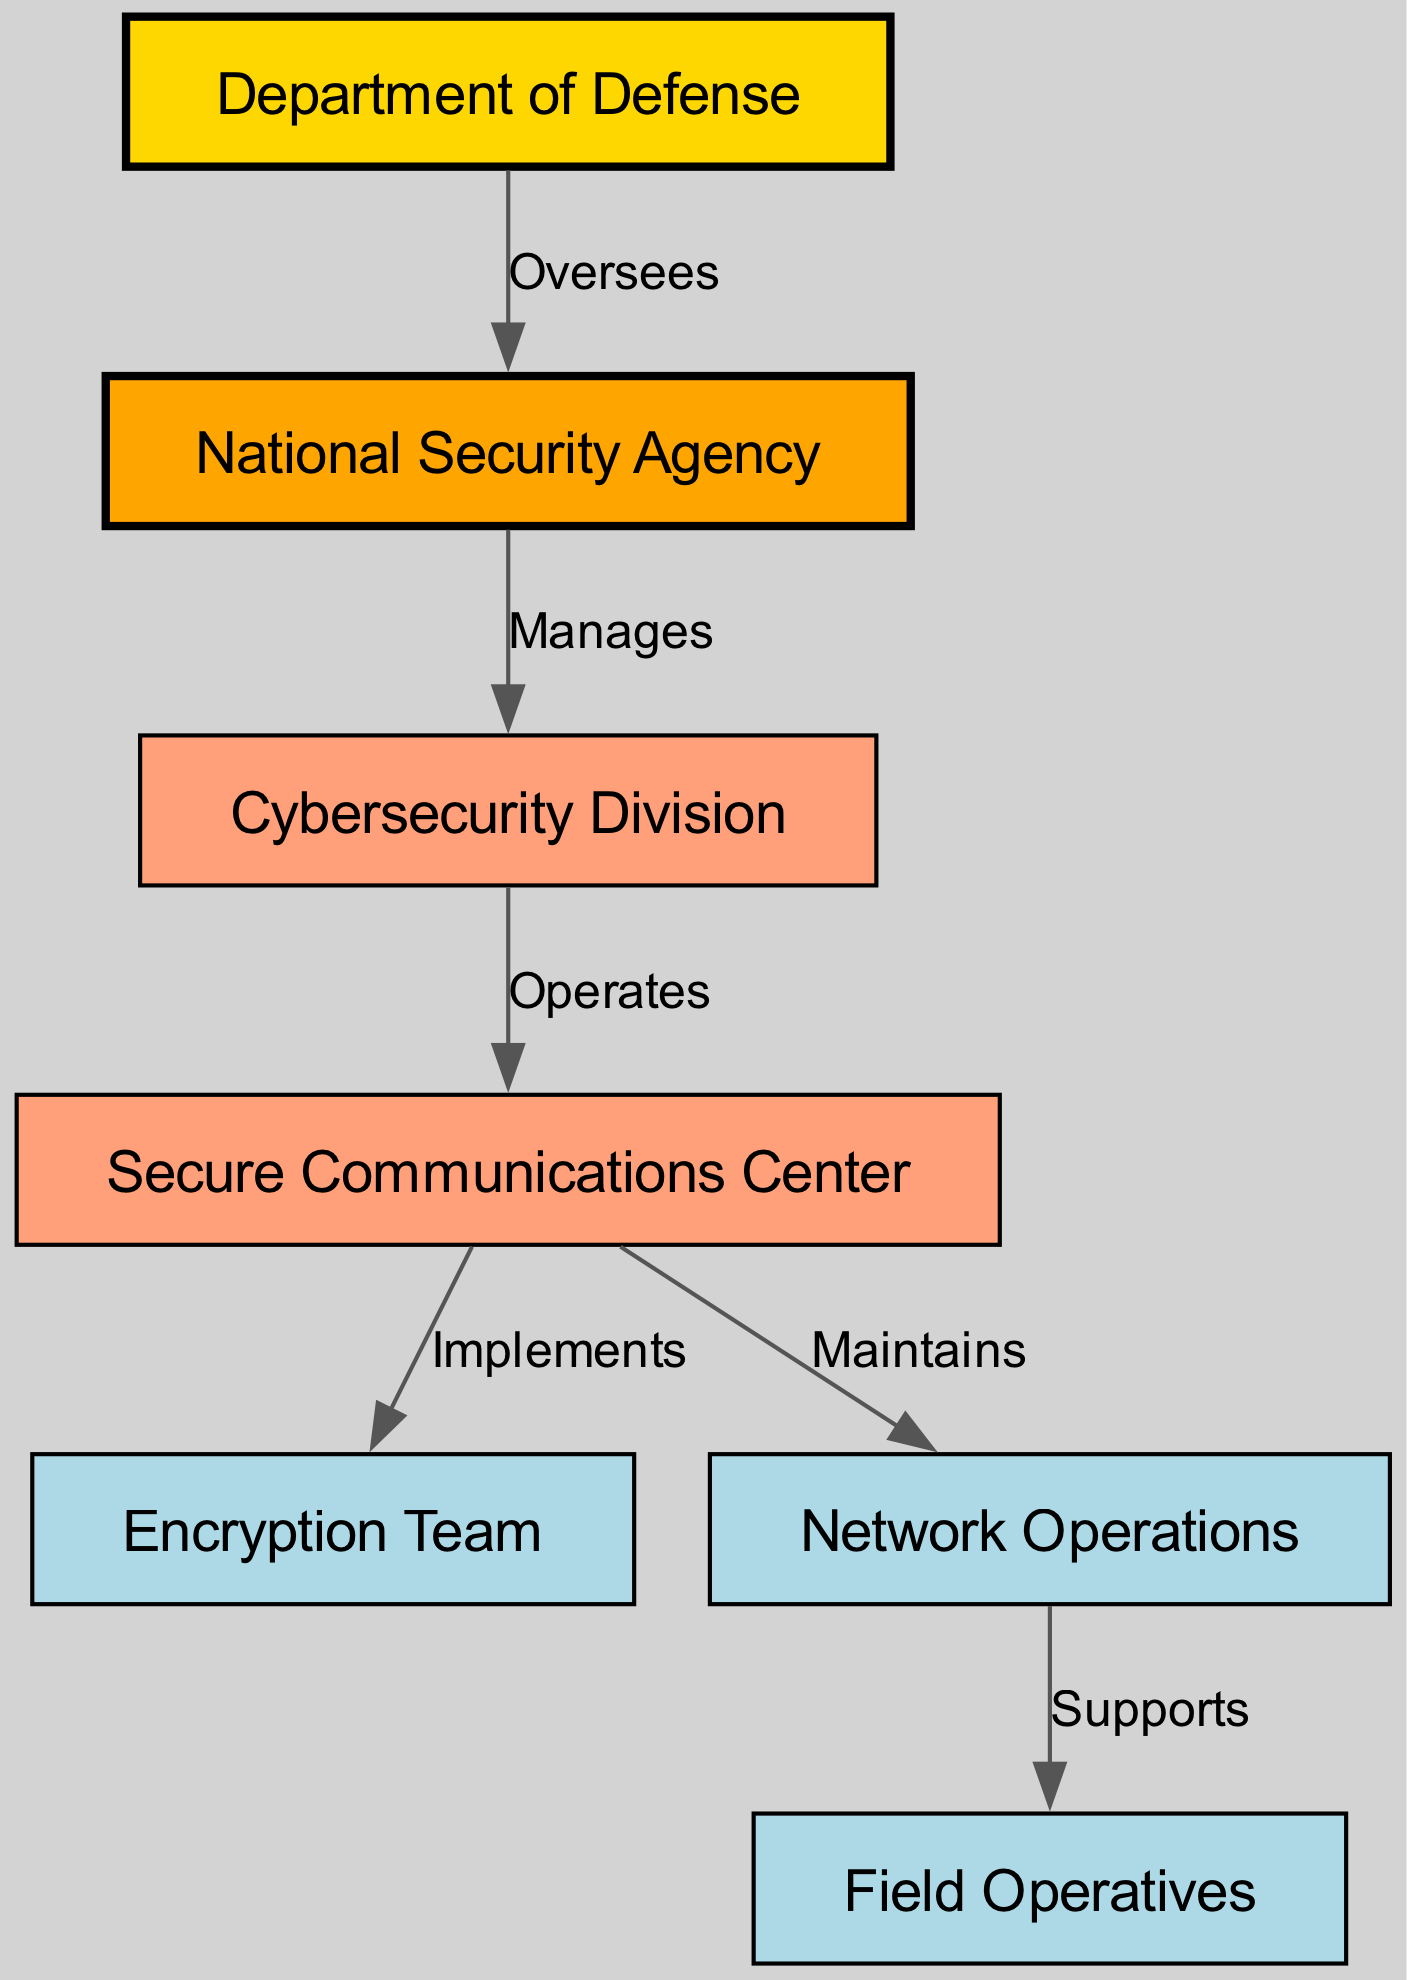What is the top-level node in the diagram? The top-level node is the Department of Defense, which has the highest authority in the organizational structure. It is the first node listed and oversees the entire communication network.
Answer: Department of Defense How many nodes are present in the diagram? The diagram contains a total of 7 nodes, each representing different entities or teams within the secure communication network.
Answer: 7 What relationship does the National Security Agency have with the Cybersecurity Division? The National Security Agency manages the Cybersecurity Division, indicating a direct supervisory role. This is defined by the arrow connecting the two nodes with the label 'Manages'.
Answer: Manages Which team directly implements the secure communications? The Encryption Team is responsible for implementing secure communications, as indicated by the direct edge from the Secure Communications Center to the Encryption Team labeled 'Implements'.
Answer: Encryption Team What nodes are involved in the maintenance of network operations? The Network Operations is maintained by the Secure Communications Center, which shows a direct relationship with the label 'Maintains' connecting these two nodes.
Answer: Secure Communications Center Which node supports Field Operatives? The Network Operations directly supports Field Operatives, as noted by the edge labeled 'Supports' from Network Operations to Field Operatives.
Answer: Network Operations What is the role of the Cybersecurity Division in the diagram? The Cybersecurity Division operates the Secure Communications Center, which shows its critical function in managing the secure communication infrastructure. This is represented by the edge labeled 'Operates'.
Answer: Operates Which node has the strongest visual prominence based on the diagram? The Department of Defense stands out visually due to its gold fill color and its position at the top, indicating its high level of authority in the organizational structure.
Answer: Department of Defense What indicates the direction of authority flow in the diagram? The arrows in the diagram indicate the direction of authority or responsibility flow among nodes. They show which entity oversees or manages another entity as delineated by their labels.
Answer: Arrows 